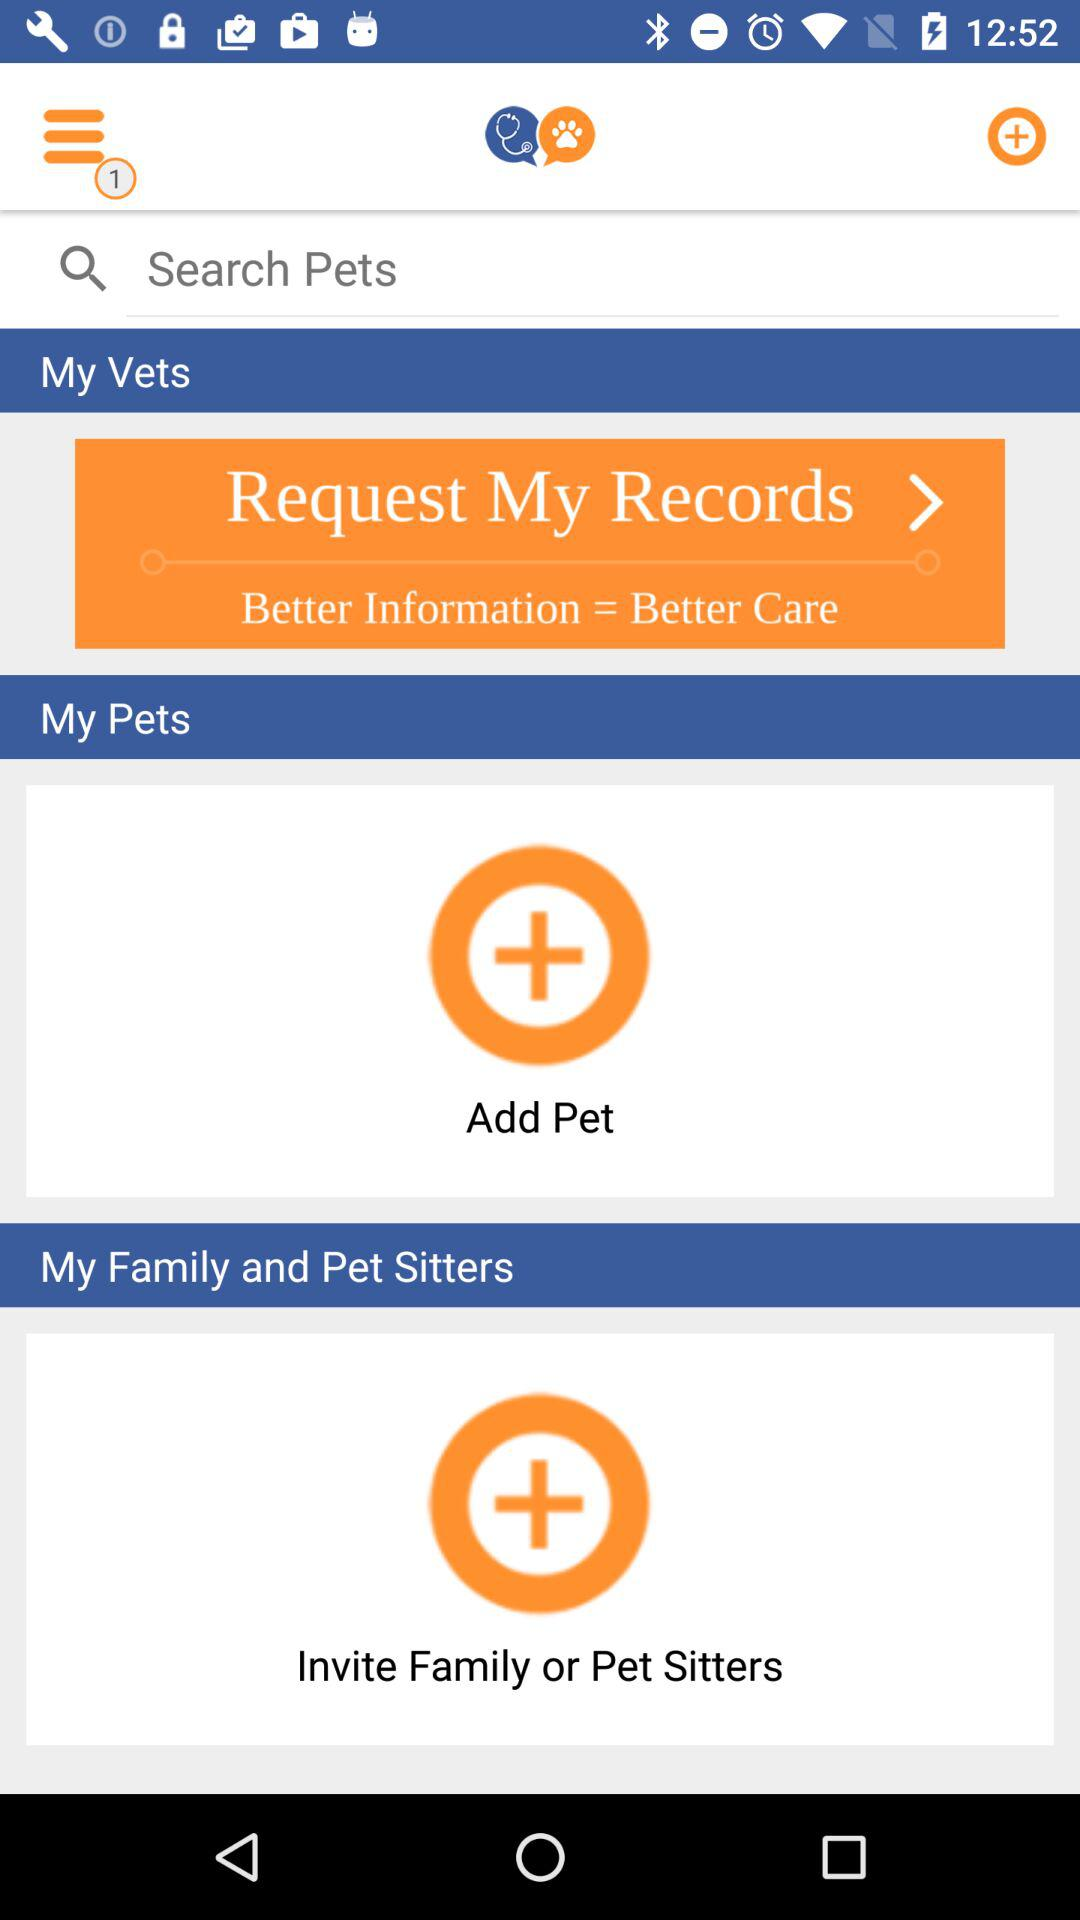What is better information equivalent to? Better information is equivalent to better care. 